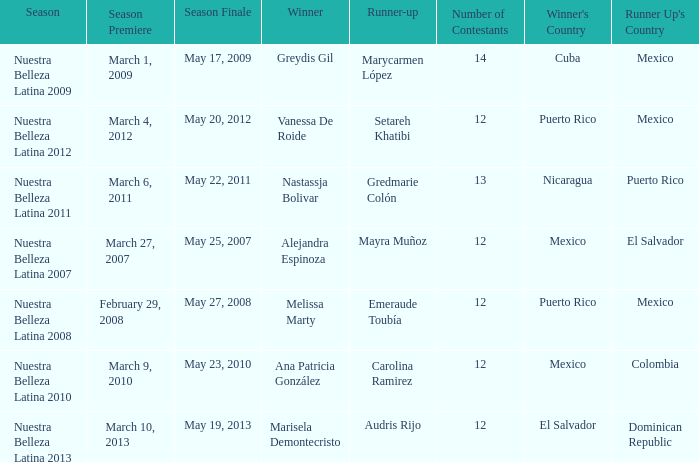What season had mexico as the runner up with melissa marty winning? Nuestra Belleza Latina 2008. 